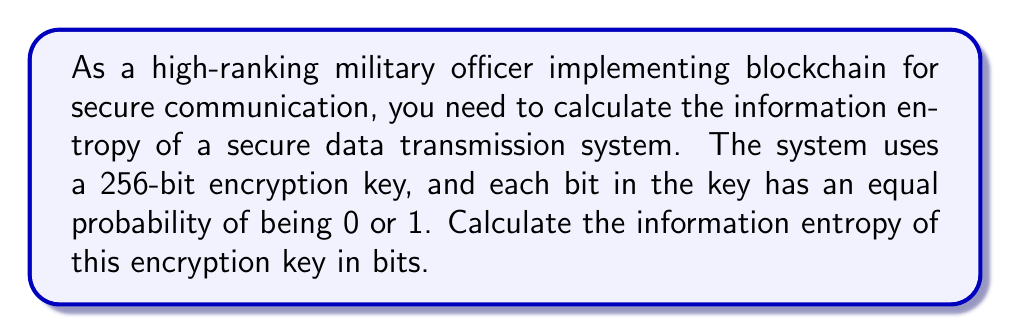Provide a solution to this math problem. To solve this problem, we'll use the formula for information entropy in bits:

$$H = -\sum_{i=1}^{n} p_i \log_2(p_i)$$

Where:
- $H$ is the information entropy in bits
- $p_i$ is the probability of each possible outcome
- $n$ is the number of possible outcomes

For a binary system (0 or 1), with equal probability for each outcome:
- $n = 2$
- $p_1 = p_2 = \frac{1}{2}$

Substituting these values:

$$\begin{align}
H &= -\left(\frac{1}{2} \log_2\left(\frac{1}{2}\right) + \frac{1}{2} \log_2\left(\frac{1}{2}\right)\right) \\[10pt]
&= -\left(\frac{1}{2} (-1) + \frac{1}{2} (-1)\right) \\[10pt]
&= -(-1) \\[10pt]
&= 1 \text{ bit}
\end{align}$$

This means each bit in the encryption key contributes 1 bit of entropy.

For a 256-bit key, the total entropy is:

$$H_{total} = 256 \times 1 \text{ bit} = 256 \text{ bits}$$

This high entropy value indicates a very secure encryption key, as it would be extremely difficult for an adversary to guess or predict the key.
Answer: The information entropy of the 256-bit encryption key is 256 bits. 